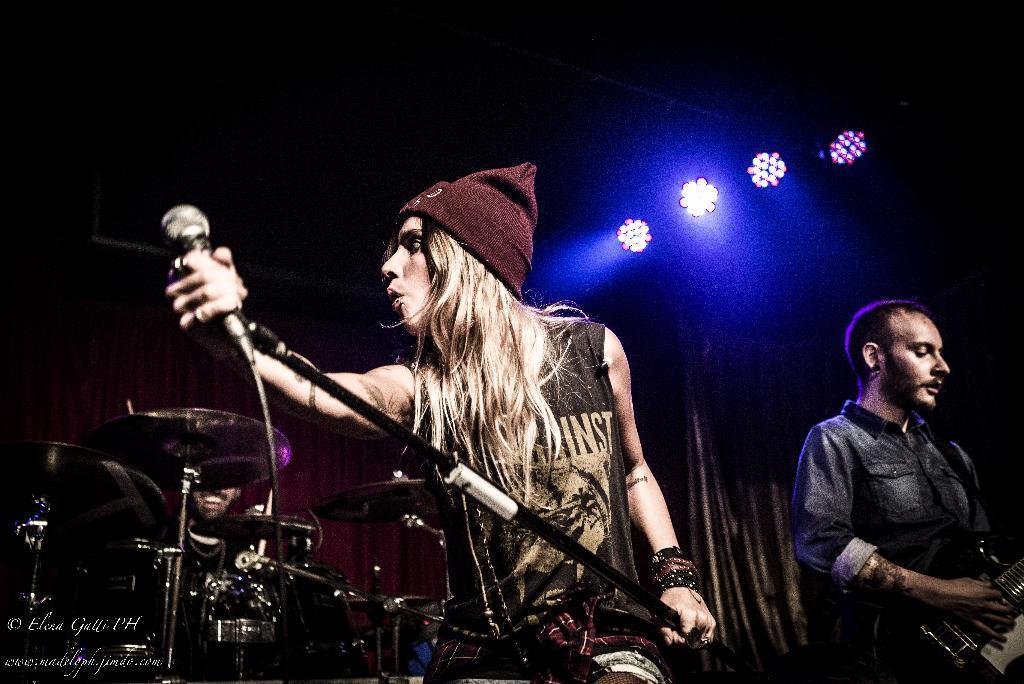Describe this image in one or two sentences. On top there are focusing lights. This man is standing and playing a guitar. This woman is holding mic and wire cap. This man is playing these musical instruments. 